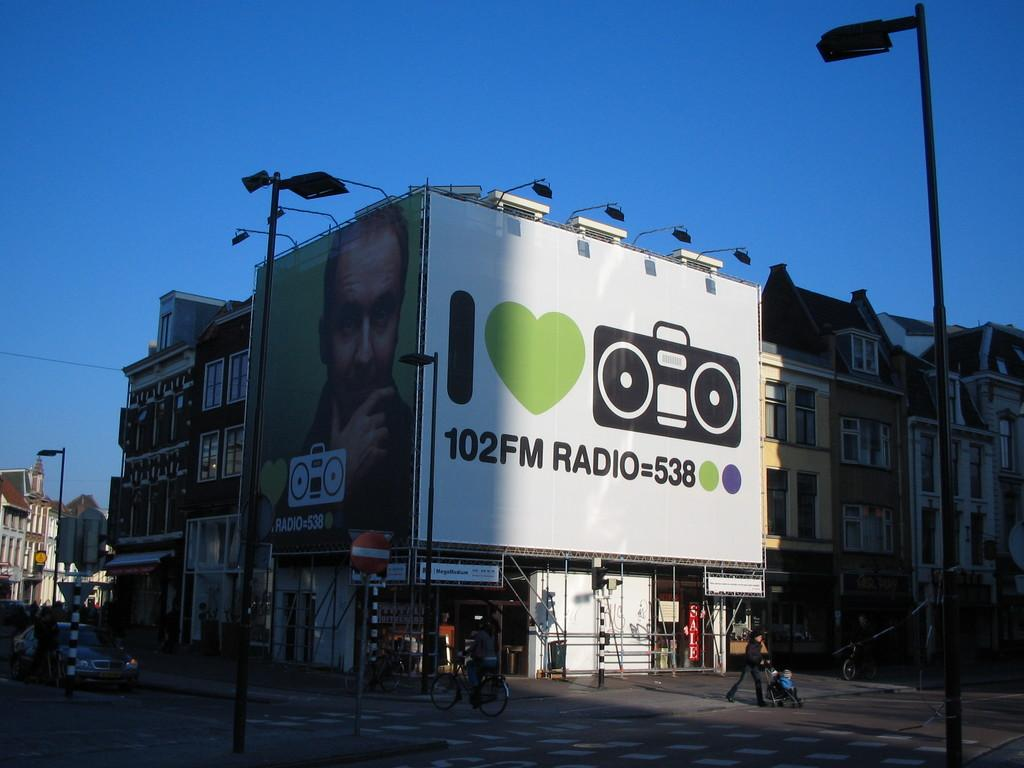Provide a one-sentence caption for the provided image. Two billboards on a building with I Heart Radio and the other of a man with a boombox. 